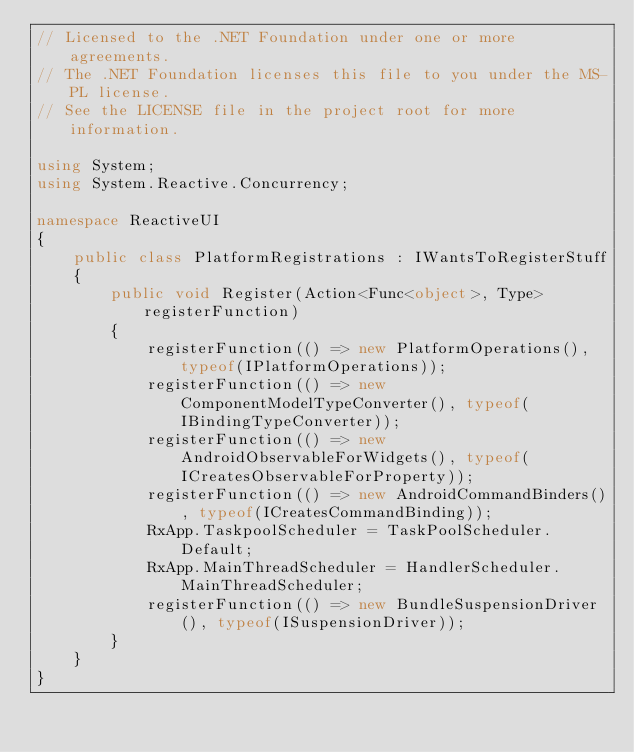Convert code to text. <code><loc_0><loc_0><loc_500><loc_500><_C#_>// Licensed to the .NET Foundation under one or more agreements. 
// The .NET Foundation licenses this file to you under the MS-PL license. 
// See the LICENSE file in the project root for more information. 

using System;
using System.Reactive.Concurrency;

namespace ReactiveUI
{
    public class PlatformRegistrations : IWantsToRegisterStuff
    {
        public void Register(Action<Func<object>, Type> registerFunction)
        {
            registerFunction(() => new PlatformOperations(), typeof(IPlatformOperations));
            registerFunction(() => new ComponentModelTypeConverter(), typeof(IBindingTypeConverter));
            registerFunction(() => new AndroidObservableForWidgets(), typeof(ICreatesObservableForProperty));
            registerFunction(() => new AndroidCommandBinders(), typeof(ICreatesCommandBinding));
            RxApp.TaskpoolScheduler = TaskPoolScheduler.Default;
            RxApp.MainThreadScheduler = HandlerScheduler.MainThreadScheduler;
            registerFunction(() => new BundleSuspensionDriver(), typeof(ISuspensionDriver));
        }
    }
}
</code> 